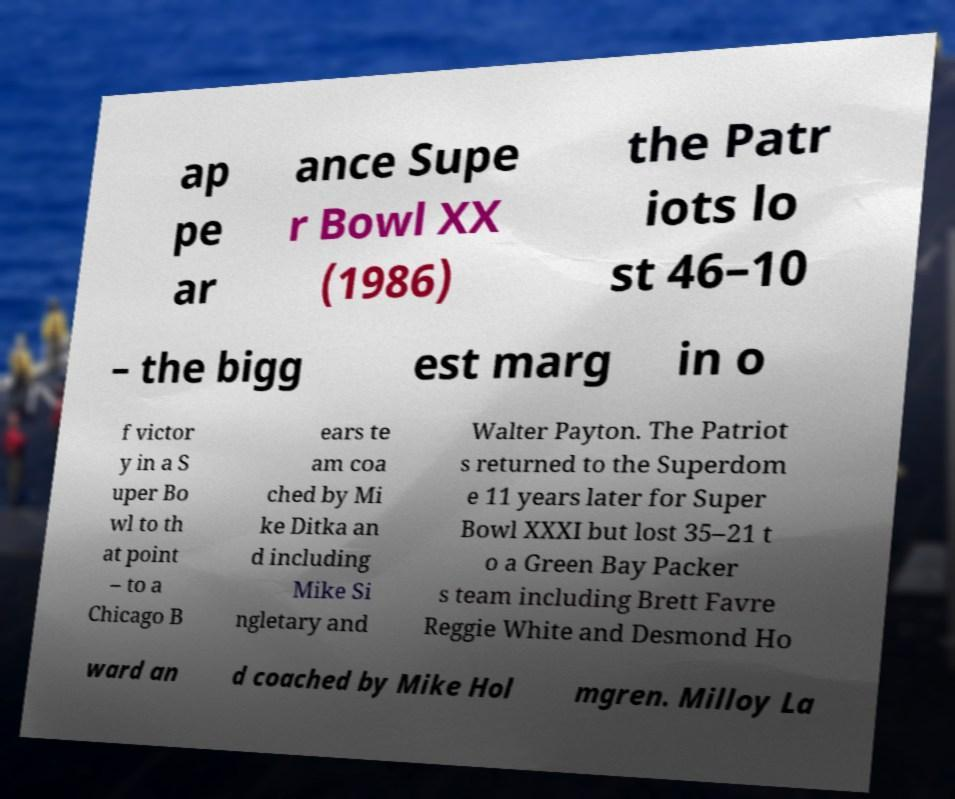Can you read and provide the text displayed in the image?This photo seems to have some interesting text. Can you extract and type it out for me? ap pe ar ance Supe r Bowl XX (1986) the Patr iots lo st 46–10 – the bigg est marg in o f victor y in a S uper Bo wl to th at point – to a Chicago B ears te am coa ched by Mi ke Ditka an d including Mike Si ngletary and Walter Payton. The Patriot s returned to the Superdom e 11 years later for Super Bowl XXXI but lost 35–21 t o a Green Bay Packer s team including Brett Favre Reggie White and Desmond Ho ward an d coached by Mike Hol mgren. Milloy La 